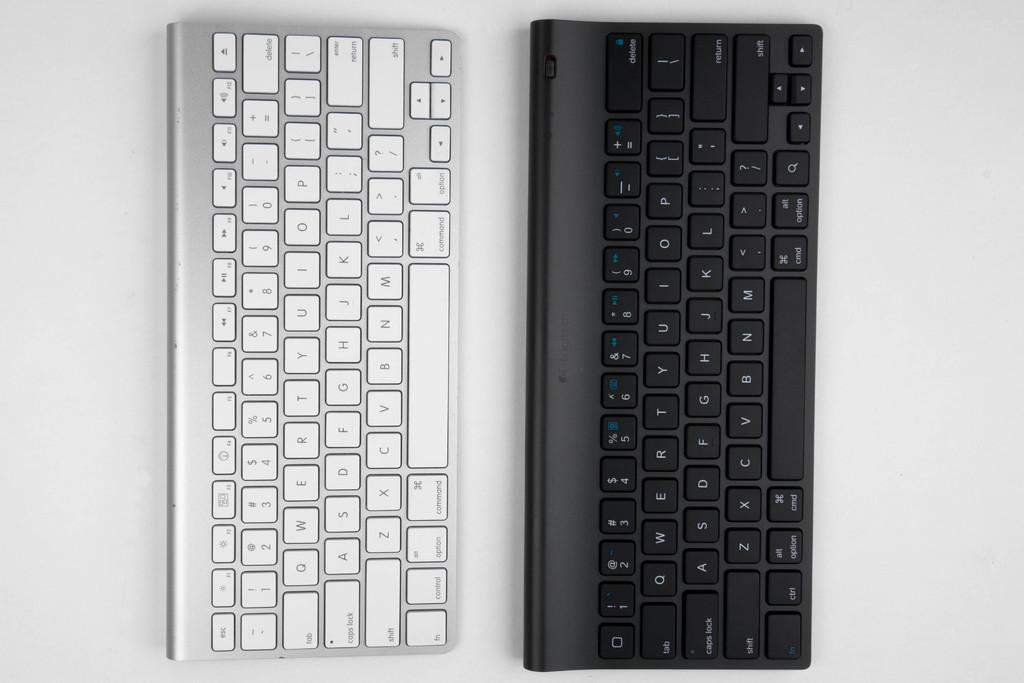<image>
Give a short and clear explanation of the subsequent image. A silver keyboard features an escape key in its top row. 